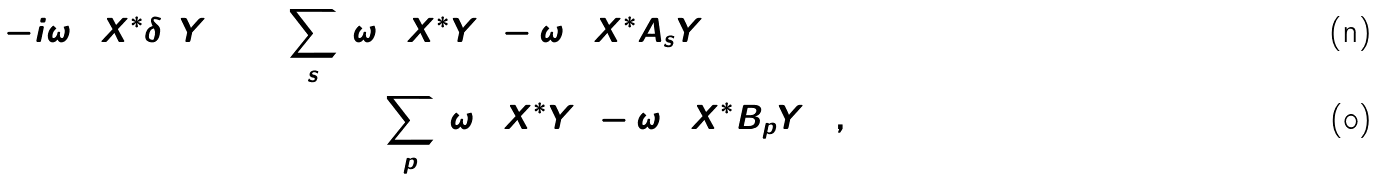Convert formula to latex. <formula><loc_0><loc_0><loc_500><loc_500>- i \omega _ { 0 } ( X ^ { * } \delta ( Y ) ) = \sum _ { s } & ( \omega _ { 0 } ( X ^ { * } Y ) - \omega _ { 0 } ( X ^ { * } A _ { s } Y ) ) \\ & + \sum _ { p } ( \omega _ { 0 } ( X ^ { * } Y ) - \omega _ { 0 } ( X ^ { * } B _ { p } Y ) ) ,</formula> 